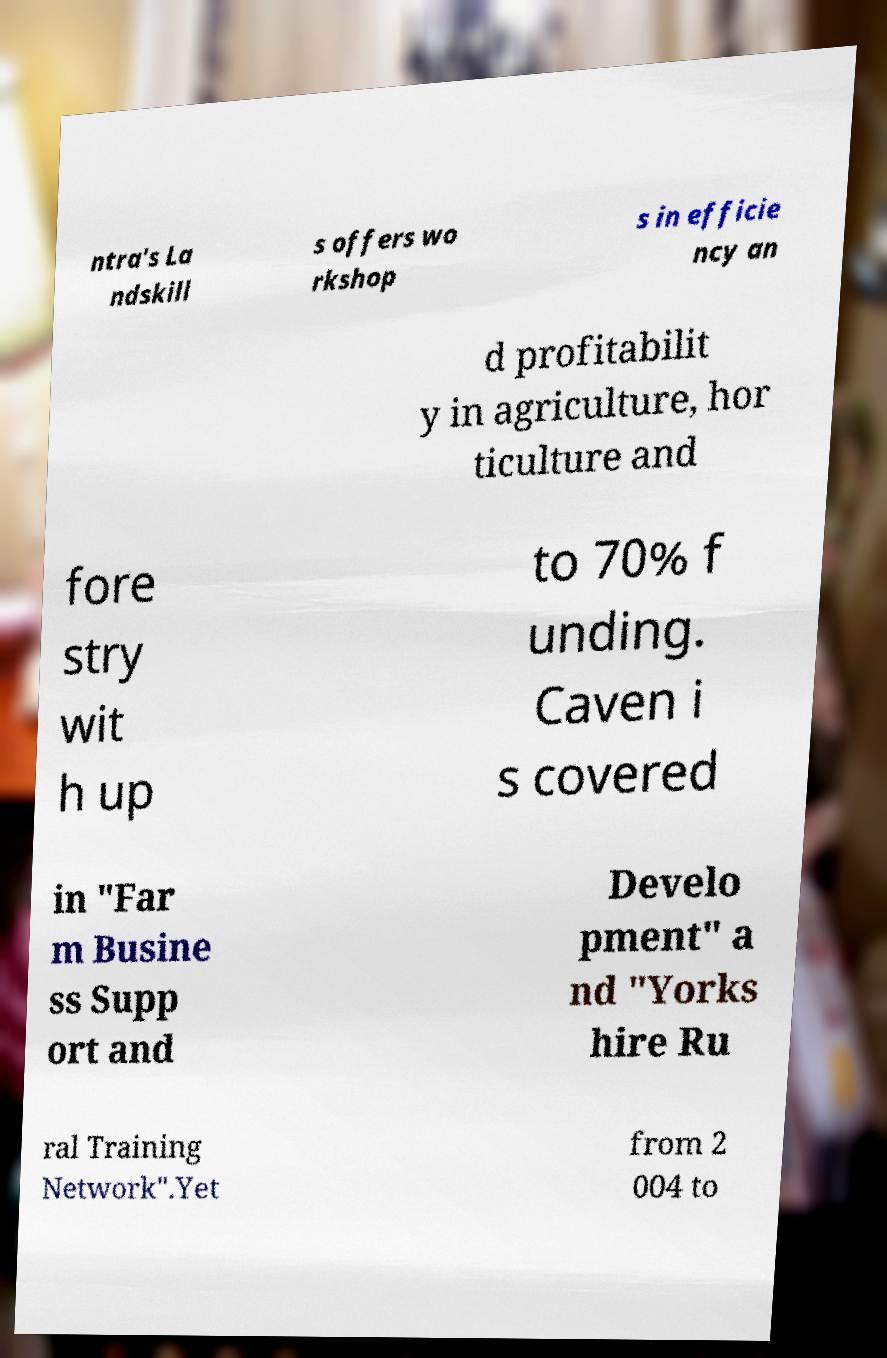For documentation purposes, I need the text within this image transcribed. Could you provide that? ntra's La ndskill s offers wo rkshop s in efficie ncy an d profitabilit y in agriculture, hor ticulture and fore stry wit h up to 70% f unding. Caven i s covered in "Far m Busine ss Supp ort and Develo pment" a nd "Yorks hire Ru ral Training Network".Yet from 2 004 to 